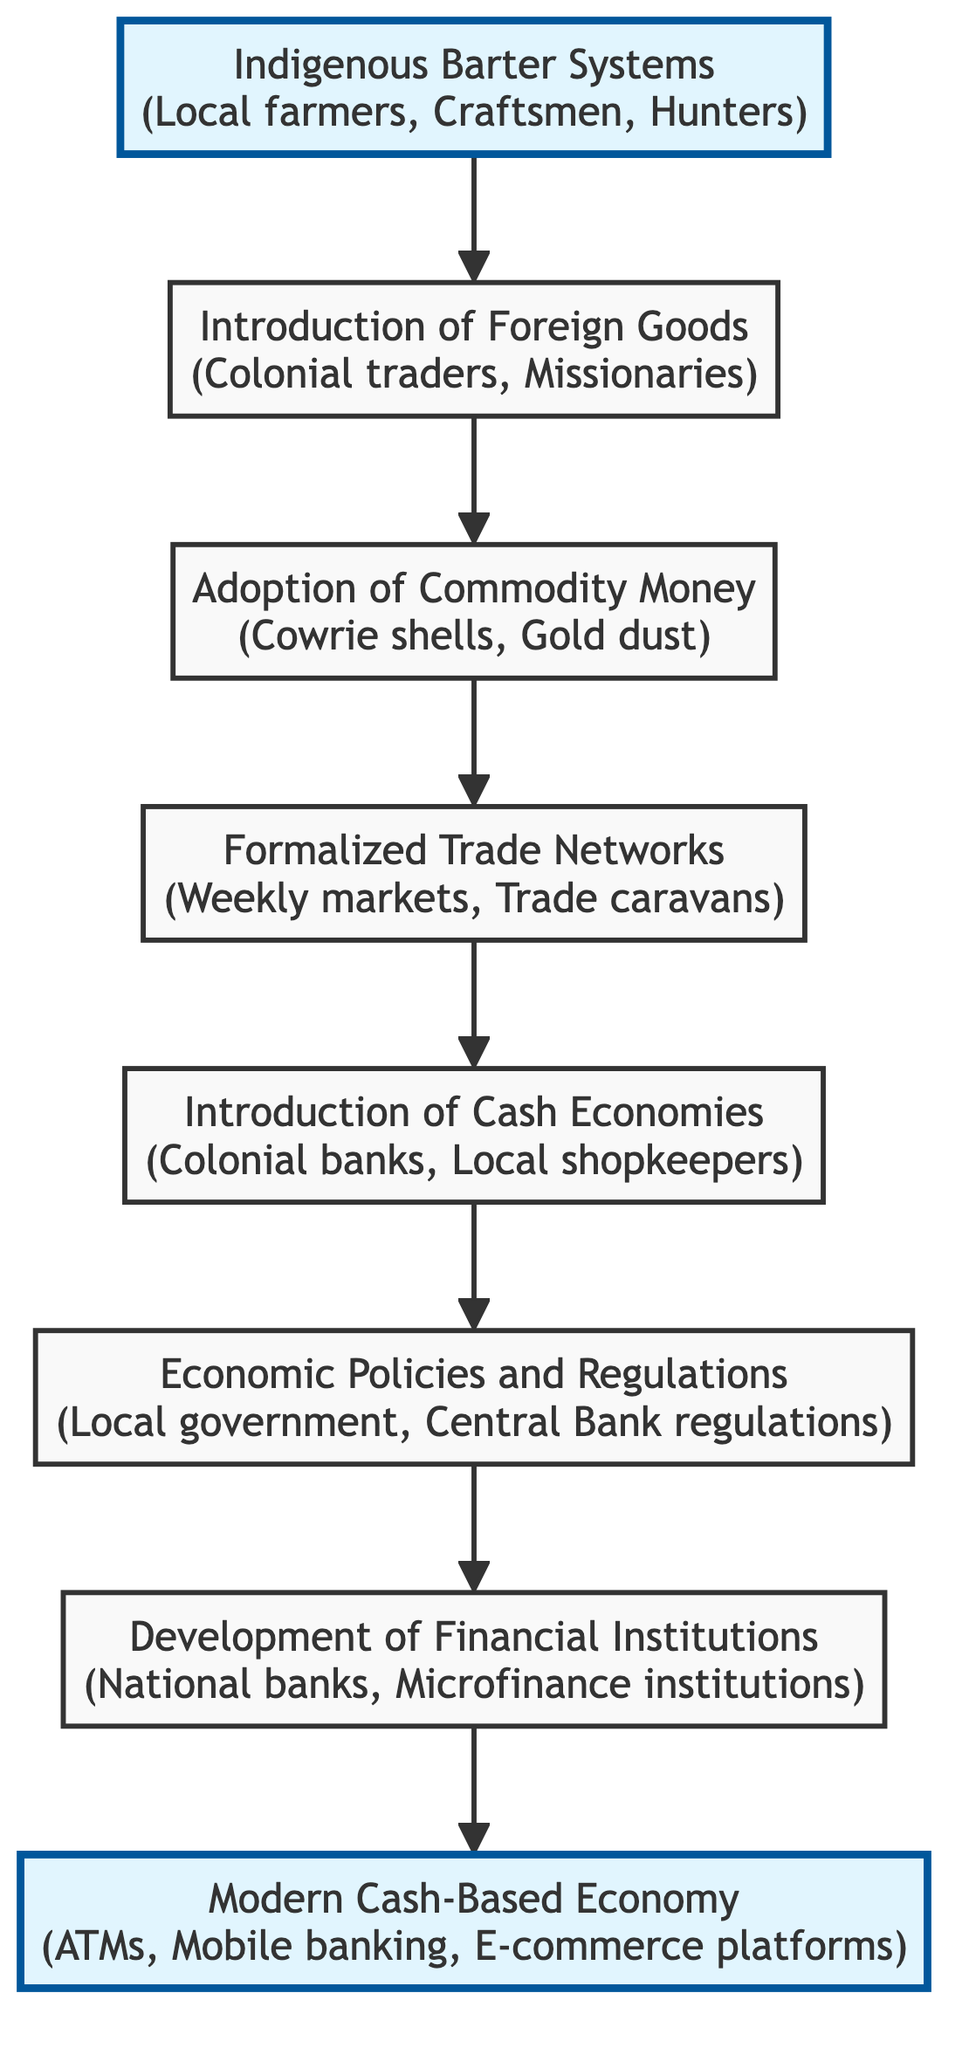What is the first node in the flowchart? The first node in the flowchart is "Indigenous Barter Systems," which is the starting point of the economic transition.
Answer: Indigenous Barter Systems How many nodes are present in the diagram? The diagram consists of 8 nodes, each representing a different stage in the economic transition process.
Answer: 8 What type of goods were introduced by the second node? The second node discusses the "Introduction of Foreign Goods," which includes imported products that require a common medium of exchange.
Answer: Foreign Goods Which real-world entities are associated with the fifth node? The fifth node "Introduction of Cash Economies" lists "Colonial banks" and "Local shopkeepers" as the real-world entities.
Answer: Colonial banks, Local shopkeepers What is the last step in the economic transition process? The last step in the economic transition is represented by the node "Modern Cash-Based Economy," which signifies the completion of the transition process.
Answer: Modern Cash-Based Economy Which node follows the "Adoption of Commodity Money"? The node that follows "Adoption of Commodity Money" is "Formalized Trade Networks," indicating the next phase in the flow of economic development.
Answer: Formalized Trade Networks What describes the relationship between nodes four and five? The relationship between nodes four ("Formalized Trade Networks") and five ("Introduction of Cash Economies") is a direct progression, showing how structured trade leads to the introduction of a cash economy.
Answer: Progression Which real-world entities are linked to the seventh node? The seventh node "Development of Financial Institutions" includes "National banks" and "Microfinance institutions" as its real-world entities supporting the cash economy.
Answer: National banks, Microfinance institutions What major transition does the flowchart depict? The flowchart depicts the major transition from traditional bartering systems to modern cash economies, outlining each step in the evolution of economic practices.
Answer: Transition from bartering to cash economies 